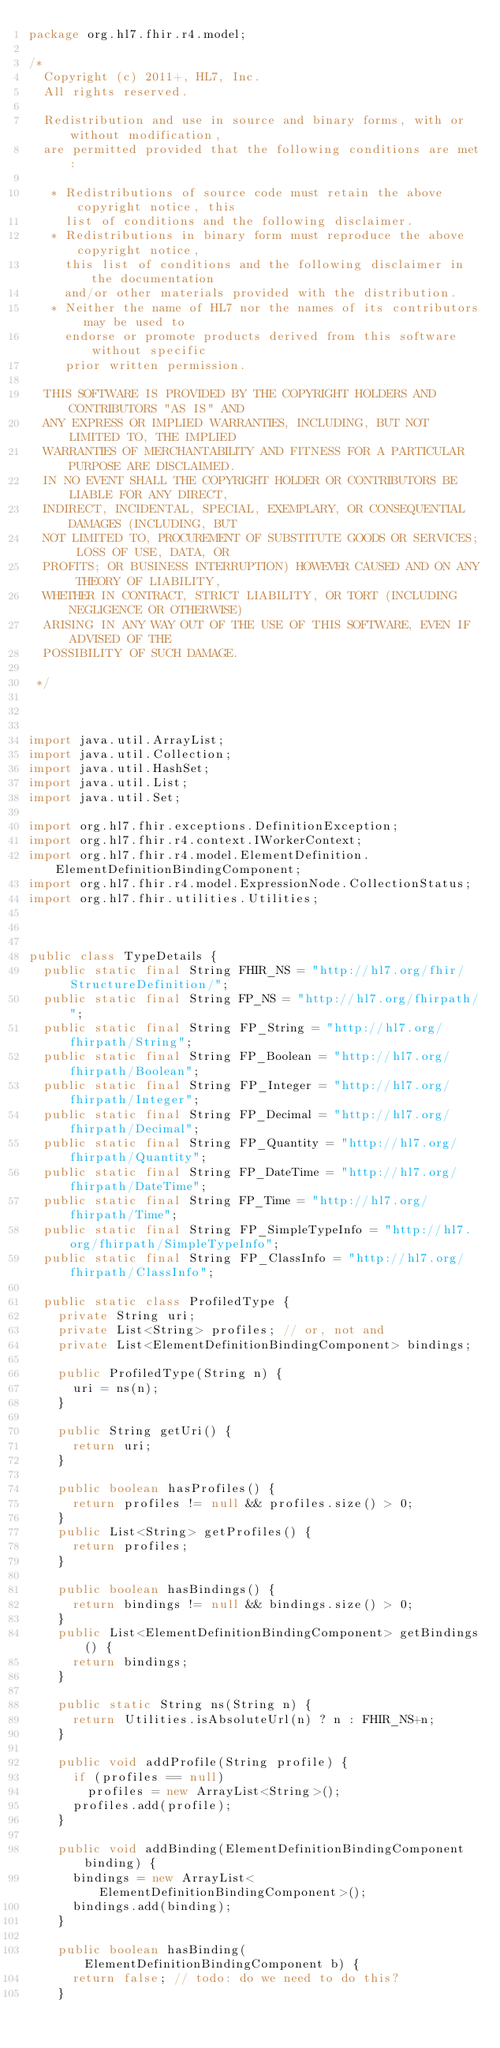<code> <loc_0><loc_0><loc_500><loc_500><_Java_>package org.hl7.fhir.r4.model;

/*
  Copyright (c) 2011+, HL7, Inc.
  All rights reserved.
  
  Redistribution and use in source and binary forms, with or without modification, 
  are permitted provided that the following conditions are met:
    
   * Redistributions of source code must retain the above copyright notice, this 
     list of conditions and the following disclaimer.
   * Redistributions in binary form must reproduce the above copyright notice, 
     this list of conditions and the following disclaimer in the documentation 
     and/or other materials provided with the distribution.
   * Neither the name of HL7 nor the names of its contributors may be used to 
     endorse or promote products derived from this software without specific 
     prior written permission.
  
  THIS SOFTWARE IS PROVIDED BY THE COPYRIGHT HOLDERS AND CONTRIBUTORS "AS IS" AND 
  ANY EXPRESS OR IMPLIED WARRANTIES, INCLUDING, BUT NOT LIMITED TO, THE IMPLIED 
  WARRANTIES OF MERCHANTABILITY AND FITNESS FOR A PARTICULAR PURPOSE ARE DISCLAIMED. 
  IN NO EVENT SHALL THE COPYRIGHT HOLDER OR CONTRIBUTORS BE LIABLE FOR ANY DIRECT, 
  INDIRECT, INCIDENTAL, SPECIAL, EXEMPLARY, OR CONSEQUENTIAL DAMAGES (INCLUDING, BUT 
  NOT LIMITED TO, PROCUREMENT OF SUBSTITUTE GOODS OR SERVICES; LOSS OF USE, DATA, OR 
  PROFITS; OR BUSINESS INTERRUPTION) HOWEVER CAUSED AND ON ANY THEORY OF LIABILITY, 
  WHETHER IN CONTRACT, STRICT LIABILITY, OR TORT (INCLUDING NEGLIGENCE OR OTHERWISE) 
  ARISING IN ANY WAY OUT OF THE USE OF THIS SOFTWARE, EVEN IF ADVISED OF THE 
  POSSIBILITY OF SUCH DAMAGE.
  
 */



import java.util.ArrayList;
import java.util.Collection;
import java.util.HashSet;
import java.util.List;
import java.util.Set;

import org.hl7.fhir.exceptions.DefinitionException;
import org.hl7.fhir.r4.context.IWorkerContext;
import org.hl7.fhir.r4.model.ElementDefinition.ElementDefinitionBindingComponent;
import org.hl7.fhir.r4.model.ExpressionNode.CollectionStatus;
import org.hl7.fhir.utilities.Utilities;



public class TypeDetails {
  public static final String FHIR_NS = "http://hl7.org/fhir/StructureDefinition/";
  public static final String FP_NS = "http://hl7.org/fhirpath/";
  public static final String FP_String = "http://hl7.org/fhirpath/String";
  public static final String FP_Boolean = "http://hl7.org/fhirpath/Boolean";
  public static final String FP_Integer = "http://hl7.org/fhirpath/Integer";
  public static final String FP_Decimal = "http://hl7.org/fhirpath/Decimal";
  public static final String FP_Quantity = "http://hl7.org/fhirpath/Quantity";
  public static final String FP_DateTime = "http://hl7.org/fhirpath/DateTime";
  public static final String FP_Time = "http://hl7.org/fhirpath/Time";
  public static final String FP_SimpleTypeInfo = "http://hl7.org/fhirpath/SimpleTypeInfo";
  public static final String FP_ClassInfo = "http://hl7.org/fhirpath/ClassInfo";

  public static class ProfiledType {
    private String uri;
    private List<String> profiles; // or, not and
    private List<ElementDefinitionBindingComponent> bindings;
    
    public ProfiledType(String n) {
      uri = ns(n);    
    }
    
    public String getUri() {
      return uri;
    }

    public boolean hasProfiles() {
      return profiles != null && profiles.size() > 0;
    }
    public List<String> getProfiles() {
      return profiles;
    }

    public boolean hasBindings() {
      return bindings != null && bindings.size() > 0;
    }
    public List<ElementDefinitionBindingComponent> getBindings() {
      return bindings;
    }

    public static String ns(String n) {
      return Utilities.isAbsoluteUrl(n) ? n : FHIR_NS+n;
    }

    public void addProfile(String profile) {
      if (profiles == null)
        profiles = new ArrayList<String>();
      profiles.add(profile);
    }

    public void addBinding(ElementDefinitionBindingComponent binding) {
      bindings = new ArrayList<ElementDefinitionBindingComponent>();
      bindings.add(binding);
    }

    public boolean hasBinding(ElementDefinitionBindingComponent b) {
      return false; // todo: do we need to do this?
    }
</code> 